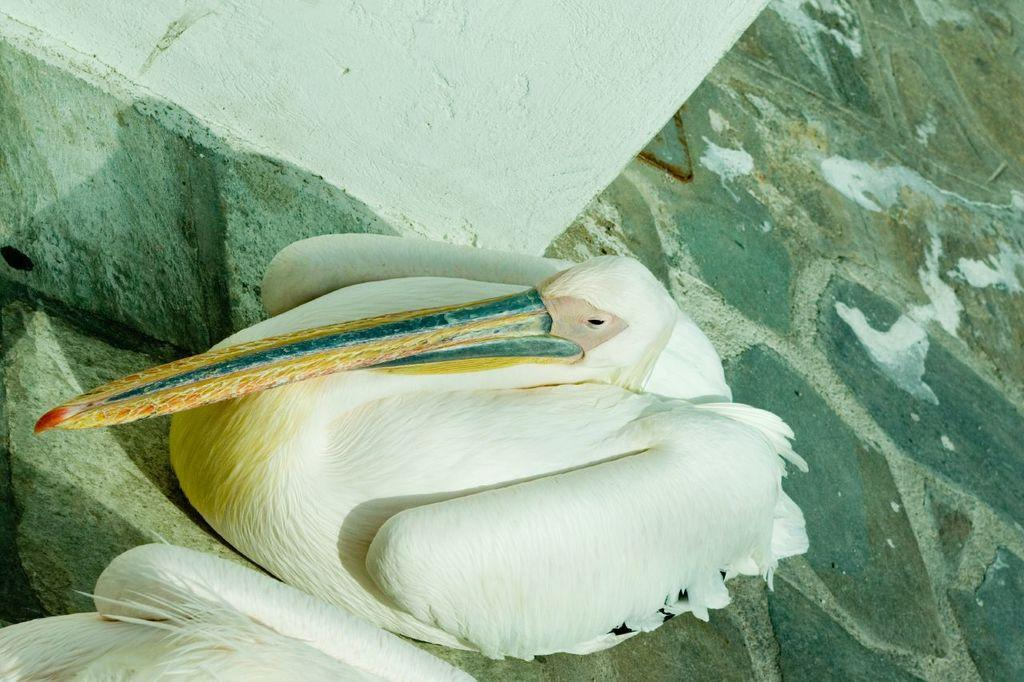What type of bird can be seen in the image? There is a white bird with a long beak in the image. Where is the bird located in the image? The bird is sitting on a path in the image. What can be seen at the top of the image? There is a white wall at the top of the image. Are there any other birds visible in the image? Yes, there is another bird in the bottom left corner of the image. What type of friction is present between the bird's feet and the path in the image? There is no information provided about the friction between the bird's feet and the path in the image. Can you describe the intricate detail of the bird's feathers in the image? The provided facts do not mention any details about the bird's feathers, so we cannot describe them. 